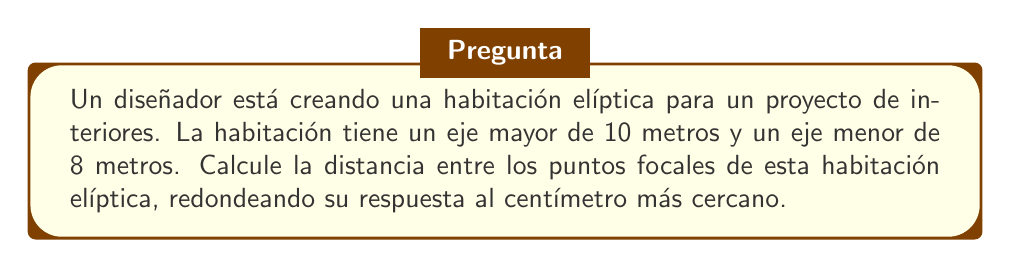Could you help me with this problem? Para resolver este problema, seguiremos estos pasos:

1) La fórmula para la distancia entre los puntos focales de una elipse es:

   $$2c = 2\sqrt{a^2 - b^2}$$

   Donde:
   $2c$ es la distancia entre los puntos focales
   $a$ es la mitad del eje mayor
   $b$ es la mitad del eje menor

2) En este caso:
   $a = 10/2 = 5$ metros
   $b = 8/2 = 4$ metros

3) Sustituyamos estos valores en la fórmula:

   $$2c = 2\sqrt{5^2 - 4^2}$$

4) Simplifiquemos dentro del radical:

   $$2c = 2\sqrt{25 - 16} = 2\sqrt{9}$$

5) Resolvamos el radical:

   $$2c = 2 \cdot 3 = 6$$

6) Por lo tanto, la distancia entre los puntos focales es de 6 metros.

7) Como se pide redondear al centímetro más cercano, la respuesta final es 600 cm.

Este cálculo es útil en diseño de interiores para determinar la posición exacta de los focos de la elipse, lo que puede influir en la colocación de elementos decorativos o en la acústica de la habitación.
Answer: 600 cm 